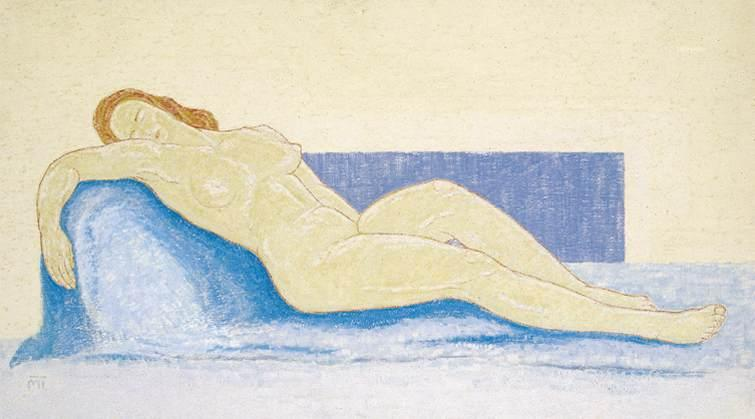Based on the image, invent a very creative and unexpected backstory. Let your imagination run wild! In a whimsical twist, this seemingly tranquil scene hides a fantastical secret. The blue couch is actually an enchanted, shape-shifting creature from a magical realm. Centuries ago, it had taken the form of a couch to escape a powerful sorcerer's grasp. The woman, a time-traveler from the future, discovered the couch's secret during her explorations. They formed an unlikely bond, with the couch regaling her with tales of its many adventures across dimensions. Whenever the woman rested on it, they would embark on shared journeys through time and space, visiting far-off worlds and witnessing historical events together. This moment captured in the image is one of their rare pauses – brief interludes between their extraordinary escapades, a peaceful respite amidst the wonders of the universe. 